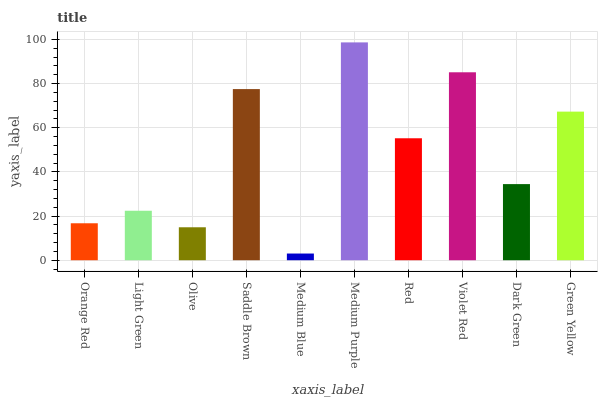Is Medium Blue the minimum?
Answer yes or no. Yes. Is Medium Purple the maximum?
Answer yes or no. Yes. Is Light Green the minimum?
Answer yes or no. No. Is Light Green the maximum?
Answer yes or no. No. Is Light Green greater than Orange Red?
Answer yes or no. Yes. Is Orange Red less than Light Green?
Answer yes or no. Yes. Is Orange Red greater than Light Green?
Answer yes or no. No. Is Light Green less than Orange Red?
Answer yes or no. No. Is Red the high median?
Answer yes or no. Yes. Is Dark Green the low median?
Answer yes or no. Yes. Is Violet Red the high median?
Answer yes or no. No. Is Orange Red the low median?
Answer yes or no. No. 